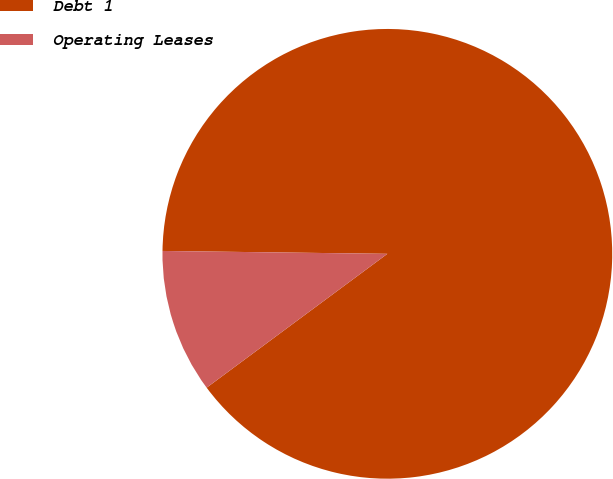Convert chart to OTSL. <chart><loc_0><loc_0><loc_500><loc_500><pie_chart><fcel>Debt 1<fcel>Operating Leases<nl><fcel>89.65%<fcel>10.35%<nl></chart> 